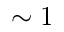<formula> <loc_0><loc_0><loc_500><loc_500>\sim 1</formula> 